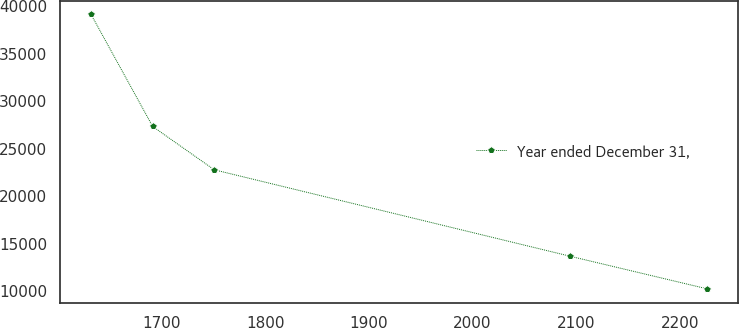Convert chart. <chart><loc_0><loc_0><loc_500><loc_500><line_chart><ecel><fcel>Year ended December 31,<nl><fcel>1632.03<fcel>39158.1<nl><fcel>1691.45<fcel>27367<nl><fcel>1750.88<fcel>22806.4<nl><fcel>2094.11<fcel>13709<nl><fcel>2226.28<fcel>10276.9<nl></chart> 